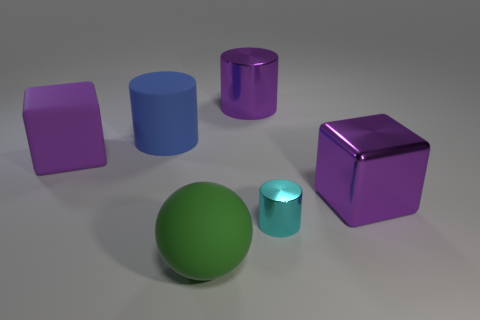Add 2 rubber cylinders. How many objects exist? 8 Subtract all spheres. How many objects are left? 5 Subtract all blue rubber cylinders. Subtract all big yellow metallic spheres. How many objects are left? 5 Add 5 matte cylinders. How many matte cylinders are left? 6 Add 2 yellow rubber balls. How many yellow rubber balls exist? 2 Subtract 1 blue cylinders. How many objects are left? 5 